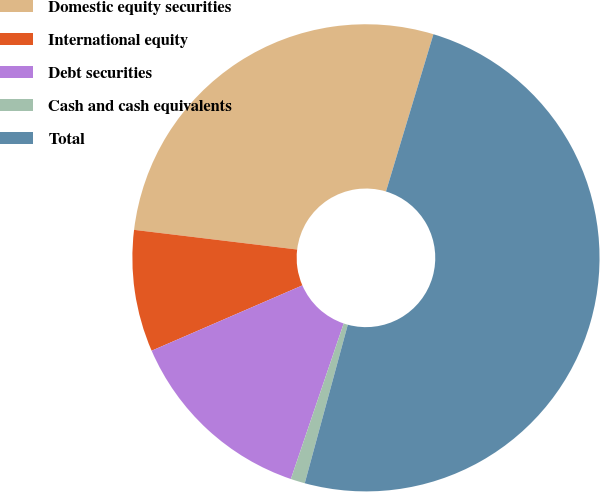<chart> <loc_0><loc_0><loc_500><loc_500><pie_chart><fcel>Domestic equity securities<fcel>International equity<fcel>Debt securities<fcel>Cash and cash equivalents<fcel>Total<nl><fcel>27.75%<fcel>8.42%<fcel>13.28%<fcel>0.99%<fcel>49.55%<nl></chart> 